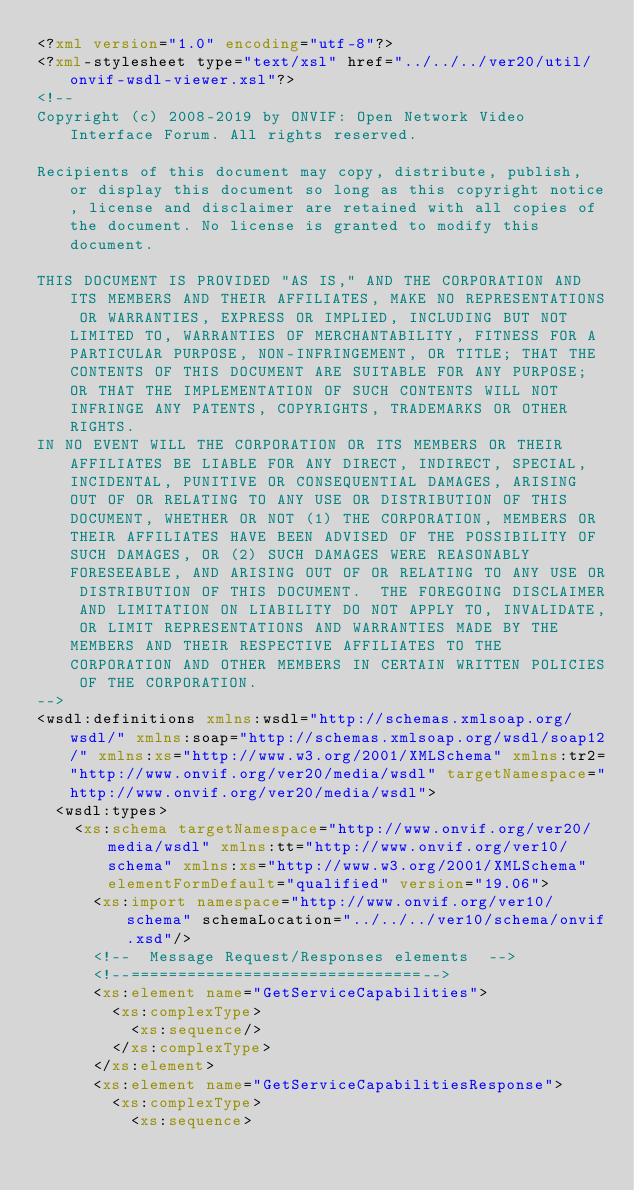Convert code to text. <code><loc_0><loc_0><loc_500><loc_500><_XML_><?xml version="1.0" encoding="utf-8"?>
<?xml-stylesheet type="text/xsl" href="../../../ver20/util/onvif-wsdl-viewer.xsl"?>
<!--
Copyright (c) 2008-2019 by ONVIF: Open Network Video Interface Forum. All rights reserved.

Recipients of this document may copy, distribute, publish, or display this document so long as this copyright notice, license and disclaimer are retained with all copies of the document. No license is granted to modify this document.

THIS DOCUMENT IS PROVIDED "AS IS," AND THE CORPORATION AND ITS MEMBERS AND THEIR AFFILIATES, MAKE NO REPRESENTATIONS OR WARRANTIES, EXPRESS OR IMPLIED, INCLUDING BUT NOT LIMITED TO, WARRANTIES OF MERCHANTABILITY, FITNESS FOR A PARTICULAR PURPOSE, NON-INFRINGEMENT, OR TITLE; THAT THE CONTENTS OF THIS DOCUMENT ARE SUITABLE FOR ANY PURPOSE; OR THAT THE IMPLEMENTATION OF SUCH CONTENTS WILL NOT INFRINGE ANY PATENTS, COPYRIGHTS, TRADEMARKS OR OTHER RIGHTS.
IN NO EVENT WILL THE CORPORATION OR ITS MEMBERS OR THEIR AFFILIATES BE LIABLE FOR ANY DIRECT, INDIRECT, SPECIAL, INCIDENTAL, PUNITIVE OR CONSEQUENTIAL DAMAGES, ARISING OUT OF OR RELATING TO ANY USE OR DISTRIBUTION OF THIS DOCUMENT, WHETHER OR NOT (1) THE CORPORATION, MEMBERS OR THEIR AFFILIATES HAVE BEEN ADVISED OF THE POSSIBILITY OF SUCH DAMAGES, OR (2) SUCH DAMAGES WERE REASONABLY FORESEEABLE, AND ARISING OUT OF OR RELATING TO ANY USE OR DISTRIBUTION OF THIS DOCUMENT.  THE FOREGOING DISCLAIMER AND LIMITATION ON LIABILITY DO NOT APPLY TO, INVALIDATE, OR LIMIT REPRESENTATIONS AND WARRANTIES MADE BY THE MEMBERS AND THEIR RESPECTIVE AFFILIATES TO THE CORPORATION AND OTHER MEMBERS IN CERTAIN WRITTEN POLICIES OF THE CORPORATION.
-->
<wsdl:definitions xmlns:wsdl="http://schemas.xmlsoap.org/wsdl/" xmlns:soap="http://schemas.xmlsoap.org/wsdl/soap12/" xmlns:xs="http://www.w3.org/2001/XMLSchema" xmlns:tr2="http://www.onvif.org/ver20/media/wsdl" targetNamespace="http://www.onvif.org/ver20/media/wsdl">
	<wsdl:types>
		<xs:schema targetNamespace="http://www.onvif.org/ver20/media/wsdl" xmlns:tt="http://www.onvif.org/ver10/schema" xmlns:xs="http://www.w3.org/2001/XMLSchema" elementFormDefault="qualified" version="19.06">
			<xs:import namespace="http://www.onvif.org/ver10/schema" schemaLocation="../../../ver10/schema/onvif.xsd"/>
			<!--  Message Request/Responses elements  -->
			<!--===============================-->
			<xs:element name="GetServiceCapabilities">
				<xs:complexType>
					<xs:sequence/>
				</xs:complexType>
			</xs:element>
			<xs:element name="GetServiceCapabilitiesResponse">
				<xs:complexType>
					<xs:sequence></code> 